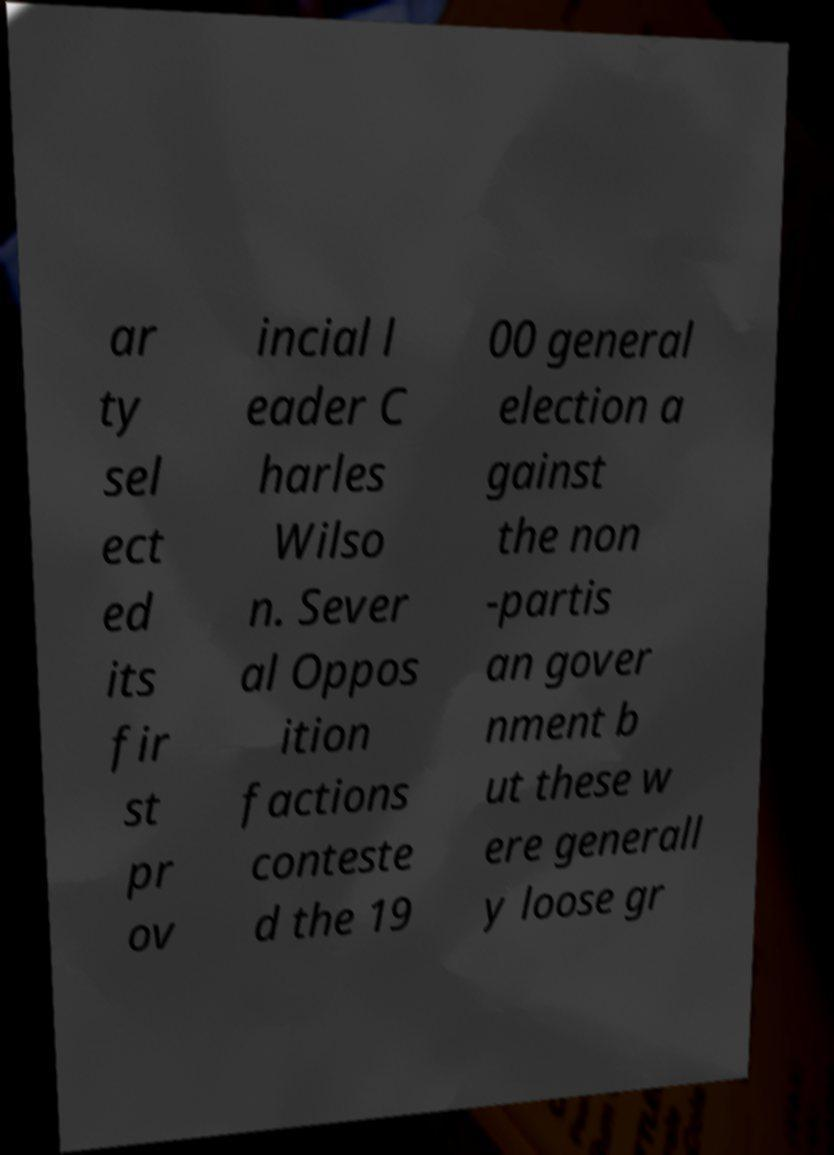Please read and relay the text visible in this image. What does it say? ar ty sel ect ed its fir st pr ov incial l eader C harles Wilso n. Sever al Oppos ition factions conteste d the 19 00 general election a gainst the non -partis an gover nment b ut these w ere generall y loose gr 